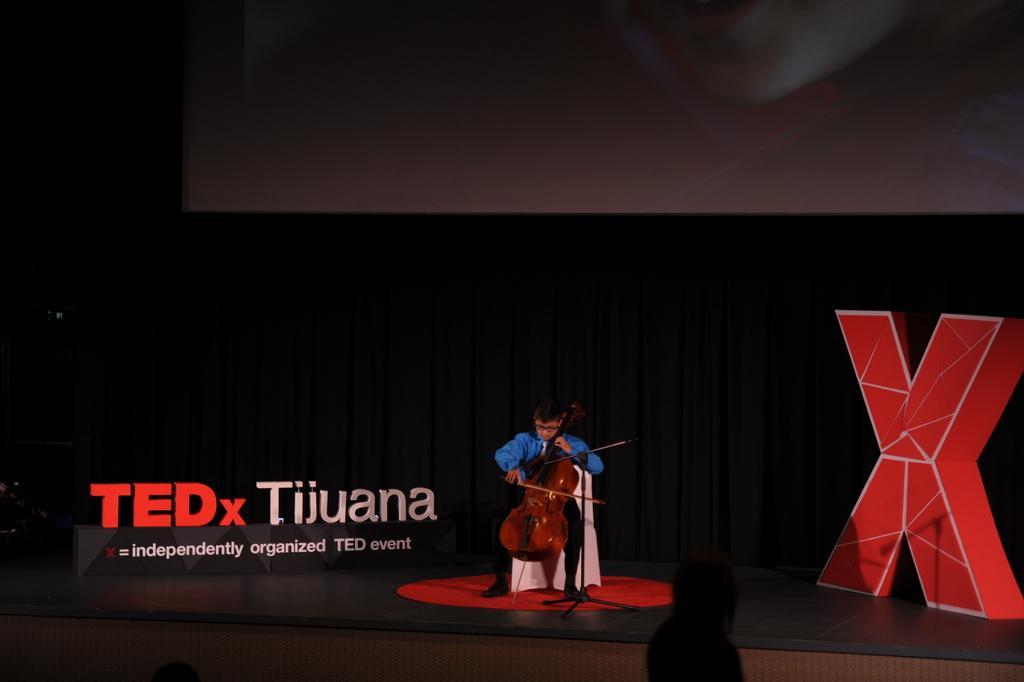Can you describe this image briefly? In this image the child is sitting on the chair and playing a violin on the stage. At the background we can see a black curtain. 